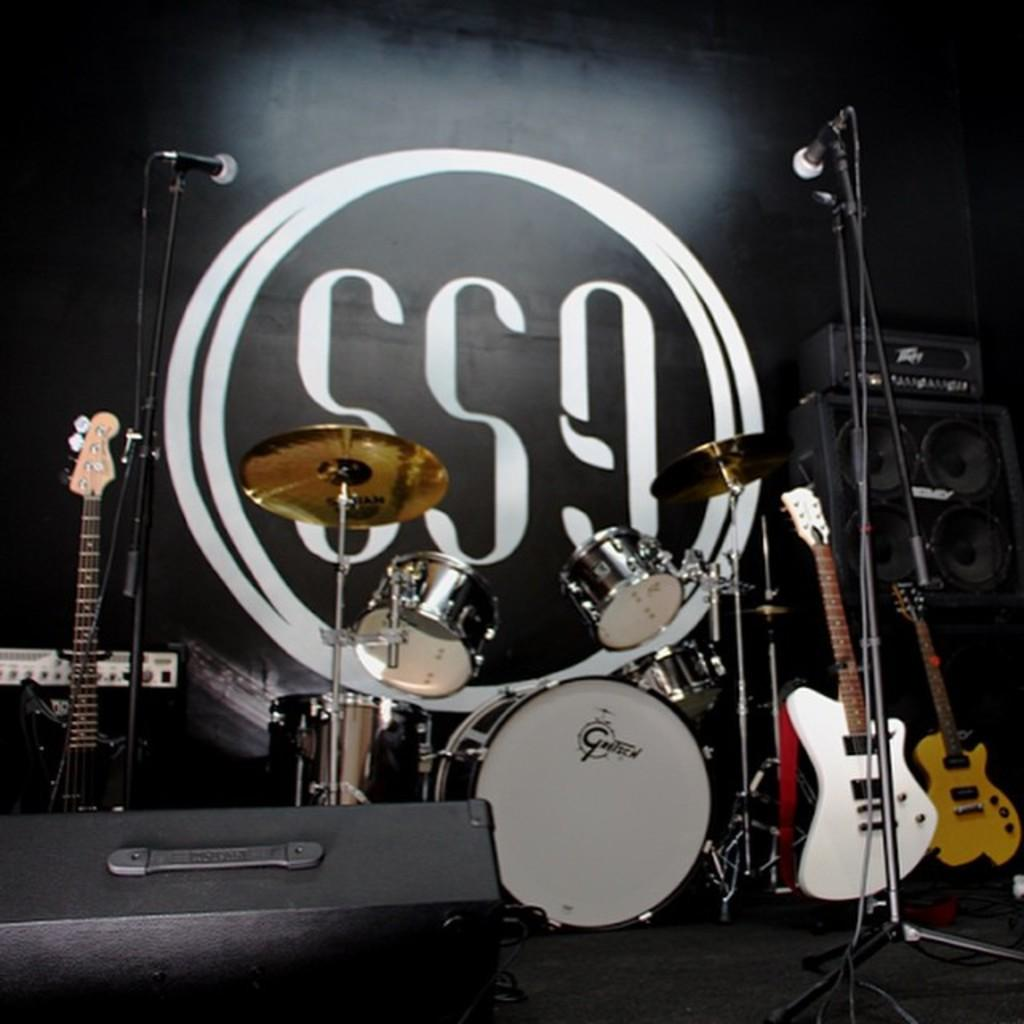What can be seen on the stage in the image? There are musical instruments on the stage. What type of performance might be taking place with these musical instruments? It is not possible to determine the specific type of performance from the image alone, but it is likely a musical performance. Can you describe the setting of the stage? The provided facts do not give information about the stage's setting, such as its size, lighting, or backdrop. What type of cast can be seen on the wall in the image? There is no cast visible on the wall in the image; the provided facts only mention musical instruments on the stage. 